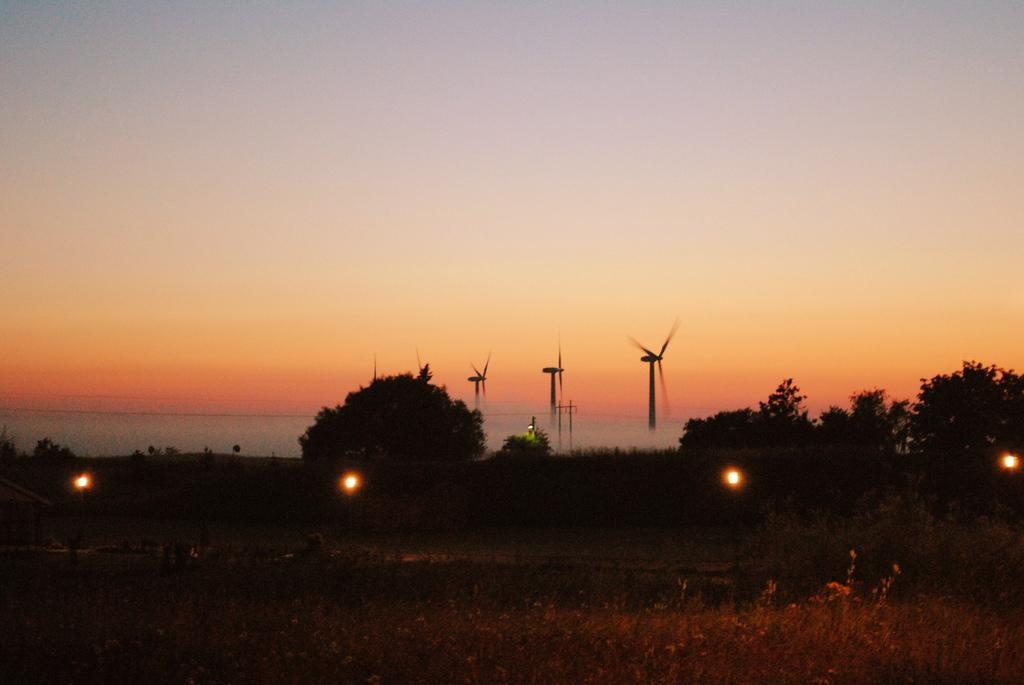What can be seen in the sky in the image? The sky is visible in the image. What type of structures are present in the image? There are windmills in the image. What type of vegetation is present in the image? There are trees and plants in the image. What type of lighting is present in the image? There are lights in the image. What other object can be seen in the image? There is a pole in the image. What type of pear is hanging from the pole in the image? There is no pear present in the image; it features windmills, trees, plants, lights, and a pole. How is the mark being used in the image? There is no mark present in the image to be used for any purpose. 